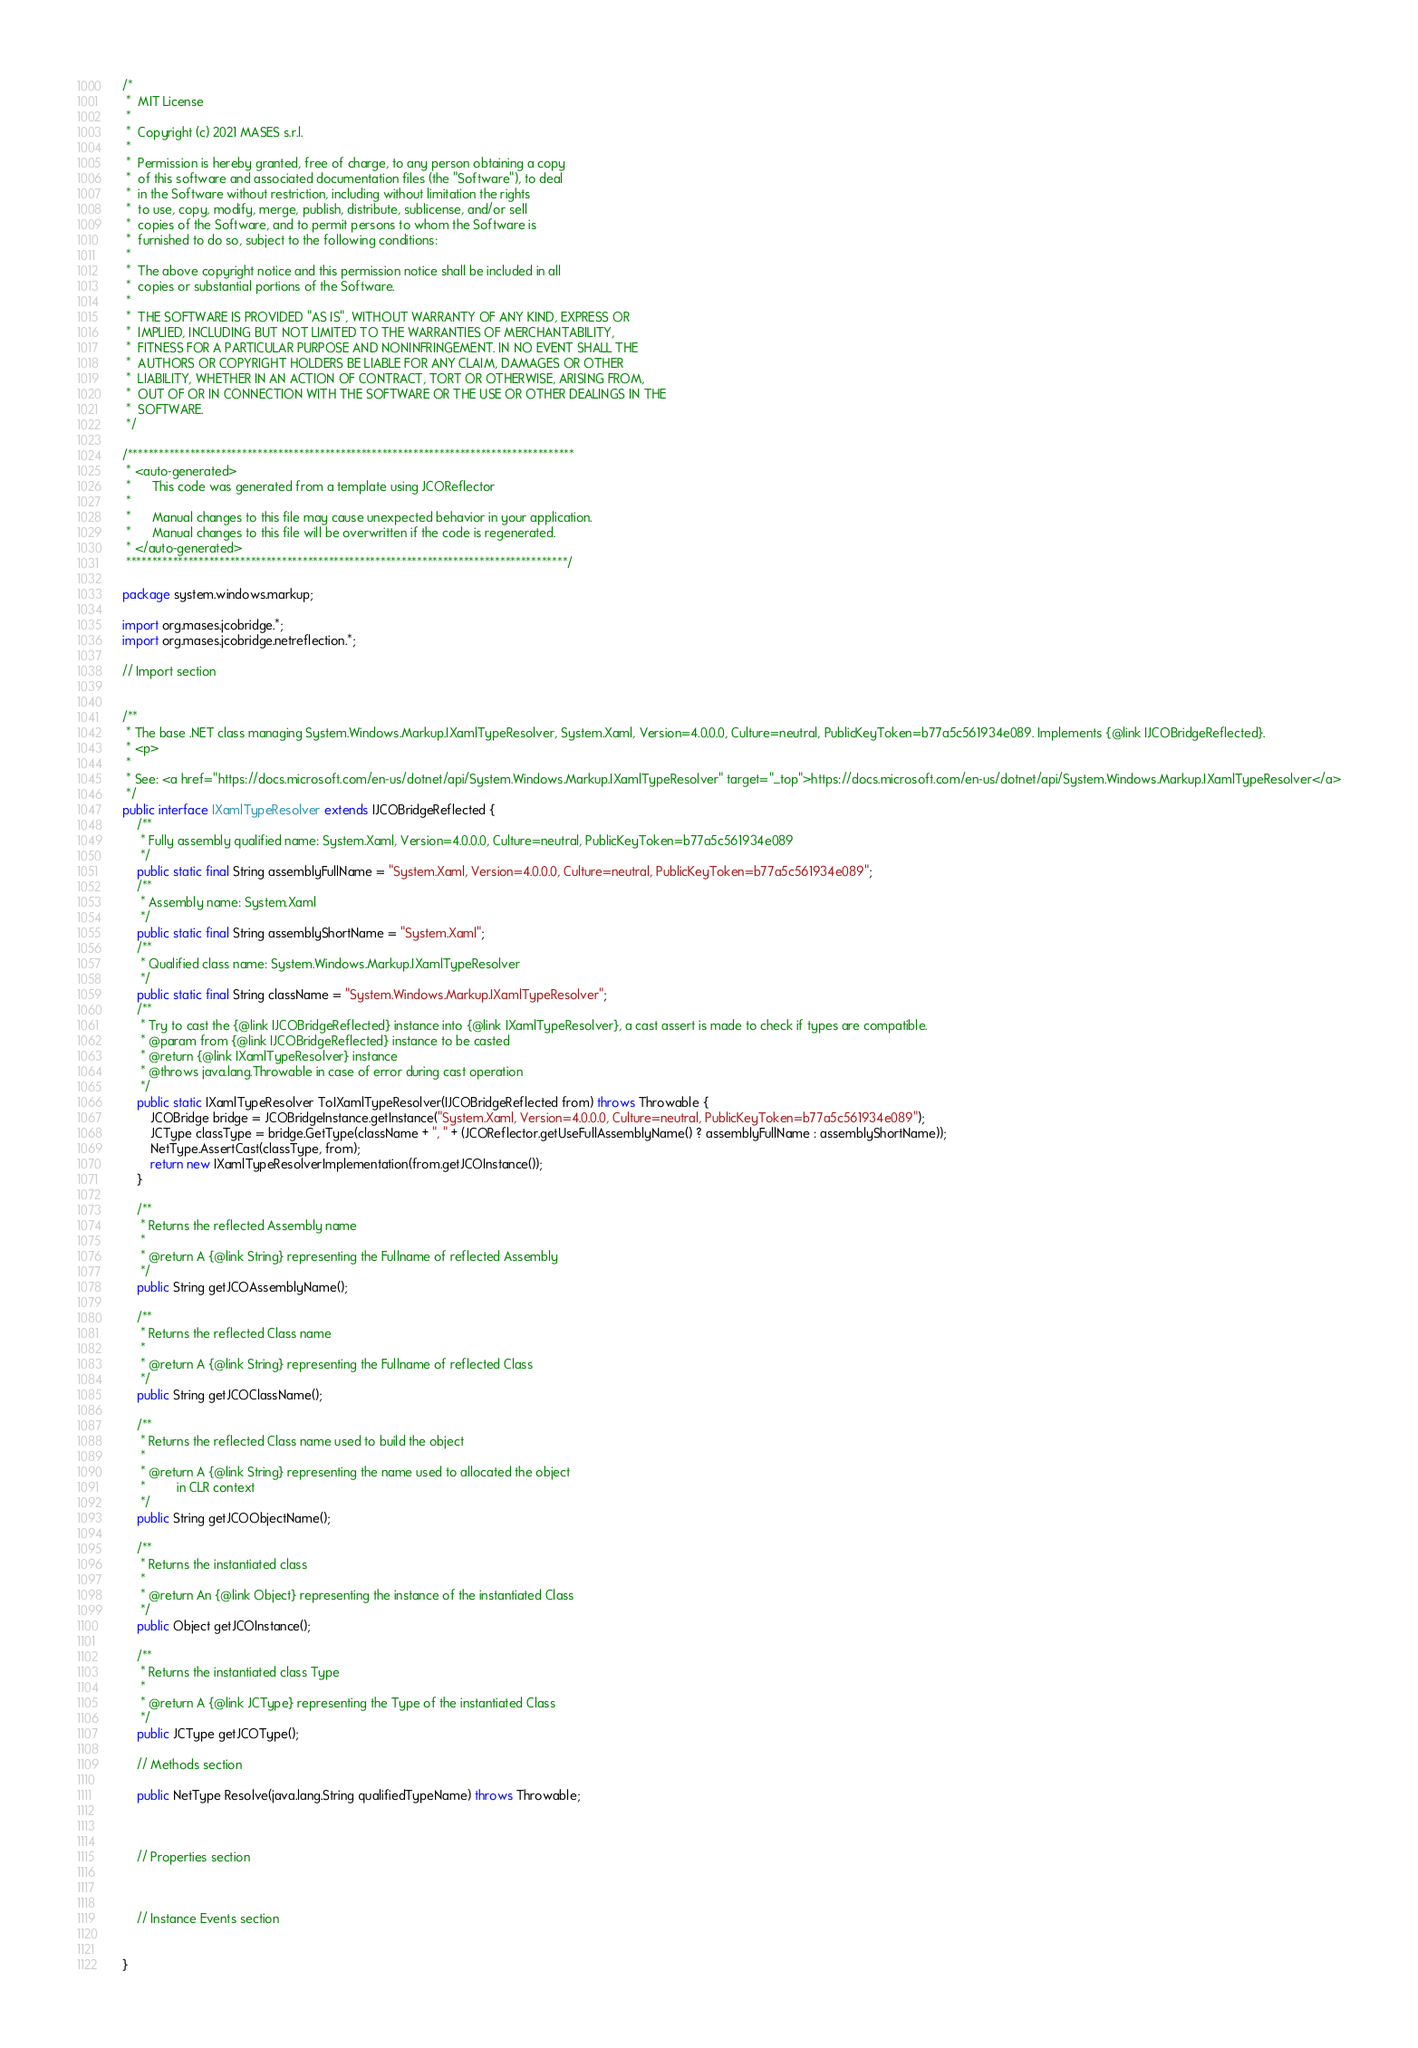<code> <loc_0><loc_0><loc_500><loc_500><_Java_>/*
 *  MIT License
 *
 *  Copyright (c) 2021 MASES s.r.l.
 *
 *  Permission is hereby granted, free of charge, to any person obtaining a copy
 *  of this software and associated documentation files (the "Software"), to deal
 *  in the Software without restriction, including without limitation the rights
 *  to use, copy, modify, merge, publish, distribute, sublicense, and/or sell
 *  copies of the Software, and to permit persons to whom the Software is
 *  furnished to do so, subject to the following conditions:
 *
 *  The above copyright notice and this permission notice shall be included in all
 *  copies or substantial portions of the Software.
 *
 *  THE SOFTWARE IS PROVIDED "AS IS", WITHOUT WARRANTY OF ANY KIND, EXPRESS OR
 *  IMPLIED, INCLUDING BUT NOT LIMITED TO THE WARRANTIES OF MERCHANTABILITY,
 *  FITNESS FOR A PARTICULAR PURPOSE AND NONINFRINGEMENT. IN NO EVENT SHALL THE
 *  AUTHORS OR COPYRIGHT HOLDERS BE LIABLE FOR ANY CLAIM, DAMAGES OR OTHER
 *  LIABILITY, WHETHER IN AN ACTION OF CONTRACT, TORT OR OTHERWISE, ARISING FROM,
 *  OUT OF OR IN CONNECTION WITH THE SOFTWARE OR THE USE OR OTHER DEALINGS IN THE
 *  SOFTWARE.
 */

/**************************************************************************************
 * <auto-generated>
 *      This code was generated from a template using JCOReflector
 * 
 *      Manual changes to this file may cause unexpected behavior in your application.
 *      Manual changes to this file will be overwritten if the code is regenerated.
 * </auto-generated>
 *************************************************************************************/

package system.windows.markup;

import org.mases.jcobridge.*;
import org.mases.jcobridge.netreflection.*;

// Import section


/**
 * The base .NET class managing System.Windows.Markup.IXamlTypeResolver, System.Xaml, Version=4.0.0.0, Culture=neutral, PublicKeyToken=b77a5c561934e089. Implements {@link IJCOBridgeReflected}.
 * <p>
 * 
 * See: <a href="https://docs.microsoft.com/en-us/dotnet/api/System.Windows.Markup.IXamlTypeResolver" target="_top">https://docs.microsoft.com/en-us/dotnet/api/System.Windows.Markup.IXamlTypeResolver</a>
 */
public interface IXamlTypeResolver extends IJCOBridgeReflected {
    /**
     * Fully assembly qualified name: System.Xaml, Version=4.0.0.0, Culture=neutral, PublicKeyToken=b77a5c561934e089
     */
    public static final String assemblyFullName = "System.Xaml, Version=4.0.0.0, Culture=neutral, PublicKeyToken=b77a5c561934e089";
    /**
     * Assembly name: System.Xaml
     */
    public static final String assemblyShortName = "System.Xaml";
    /**
     * Qualified class name: System.Windows.Markup.IXamlTypeResolver
     */
    public static final String className = "System.Windows.Markup.IXamlTypeResolver";
    /**
     * Try to cast the {@link IJCOBridgeReflected} instance into {@link IXamlTypeResolver}, a cast assert is made to check if types are compatible.
     * @param from {@link IJCOBridgeReflected} instance to be casted
     * @return {@link IXamlTypeResolver} instance
     * @throws java.lang.Throwable in case of error during cast operation
     */
    public static IXamlTypeResolver ToIXamlTypeResolver(IJCOBridgeReflected from) throws Throwable {
        JCOBridge bridge = JCOBridgeInstance.getInstance("System.Xaml, Version=4.0.0.0, Culture=neutral, PublicKeyToken=b77a5c561934e089");
        JCType classType = bridge.GetType(className + ", " + (JCOReflector.getUseFullAssemblyName() ? assemblyFullName : assemblyShortName));
        NetType.AssertCast(classType, from);
        return new IXamlTypeResolverImplementation(from.getJCOInstance());
    }

    /**
     * Returns the reflected Assembly name
     * 
     * @return A {@link String} representing the Fullname of reflected Assembly
     */
    public String getJCOAssemblyName();

    /**
     * Returns the reflected Class name
     * 
     * @return A {@link String} representing the Fullname of reflected Class
     */
    public String getJCOClassName();

    /**
     * Returns the reflected Class name used to build the object
     * 
     * @return A {@link String} representing the name used to allocated the object
     *         in CLR context
     */
    public String getJCOObjectName();

    /**
     * Returns the instantiated class
     * 
     * @return An {@link Object} representing the instance of the instantiated Class
     */
    public Object getJCOInstance();

    /**
     * Returns the instantiated class Type
     * 
     * @return A {@link JCType} representing the Type of the instantiated Class
     */
    public JCType getJCOType();

    // Methods section
    
    public NetType Resolve(java.lang.String qualifiedTypeName) throws Throwable;


    
    // Properties section
    


    // Instance Events section
    

}</code> 